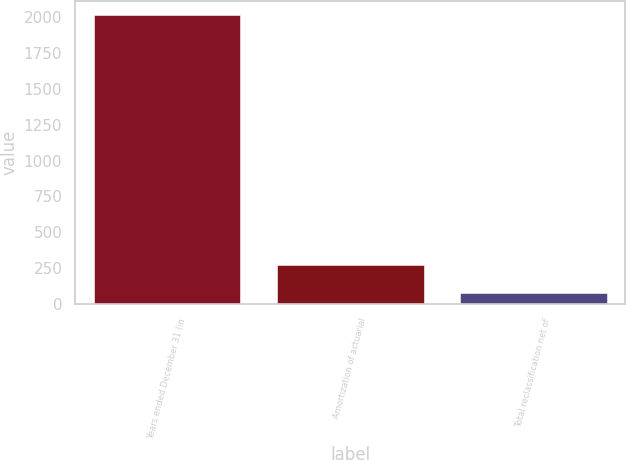<chart> <loc_0><loc_0><loc_500><loc_500><bar_chart><fcel>Years ended December 31 (in<fcel>Amortization of actuarial<fcel>Total reclassification net of<nl><fcel>2013<fcel>272.4<fcel>79<nl></chart> 